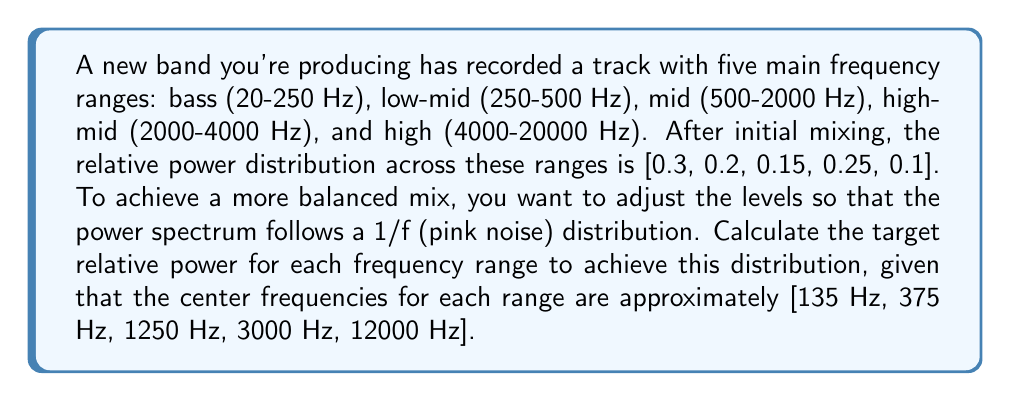Help me with this question. To solve this problem, we need to follow these steps:

1) The 1/f (pink noise) distribution means that the power spectral density is inversely proportional to the frequency. In other words, $P(f) \propto \frac{1}{f}$.

2) We need to calculate the relative power for each frequency range based on their center frequencies. Let's call the proportionality constant $k$. Then:

   $P(f) = \frac{k}{f}$

3) For each frequency range, we calculate:

   Bass: $P(135) = \frac{k}{135}$
   Low-mid: $P(375) = \frac{k}{375}$
   Mid: $P(1250) = \frac{k}{1250}$
   High-mid: $P(3000) = \frac{k}{3000}$
   High: $P(12000) = \frac{k}{12000}$

4) To get the relative powers, we need to normalize these values so they sum to 1. Let's call the sum of these values $S$:

   $S = \frac{k}{135} + \frac{k}{375} + \frac{k}{1250} + \frac{k}{3000} + \frac{k}{12000}$

5) Now, we can calculate the relative power for each range:

   Bass: $\frac{\frac{k}{135}}{S} = \frac{1/135}{1/135 + 1/375 + 1/1250 + 1/3000 + 1/12000}$

   Low-mid: $\frac{\frac{k}{375}}{S} = \frac{1/375}{1/135 + 1/375 + 1/1250 + 1/3000 + 1/12000}$

   Mid: $\frac{\frac{k}{1250}}{S} = \frac{1/1250}{1/135 + 1/375 + 1/1250 + 1/3000 + 1/12000}$

   High-mid: $\frac{\frac{k}{3000}}{S} = \frac{1/3000}{1/135 + 1/375 + 1/1250 + 1/3000 + 1/12000}$

   High: $\frac{\frac{k}{12000}}{S} = \frac{1/12000}{1/135 + 1/375 + 1/1250 + 1/3000 + 1/12000}$

6) Calculating these values:

   Bass: 0.5185
   Low-mid: 0.1867
   Mid: 0.0560
   High-mid: 0.0233
   High: 0.0058

7) Rounding to two decimal places for practicality in audio mixing:

   Bass: 0.52
   Low-mid: 0.19
   Mid: 0.06
   High-mid: 0.02
   High: 0.01
Answer: [0.52, 0.19, 0.06, 0.02, 0.01] 